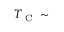Convert formula to latex. <formula><loc_0><loc_0><loc_500><loc_500>T _ { C } \sim</formula> 